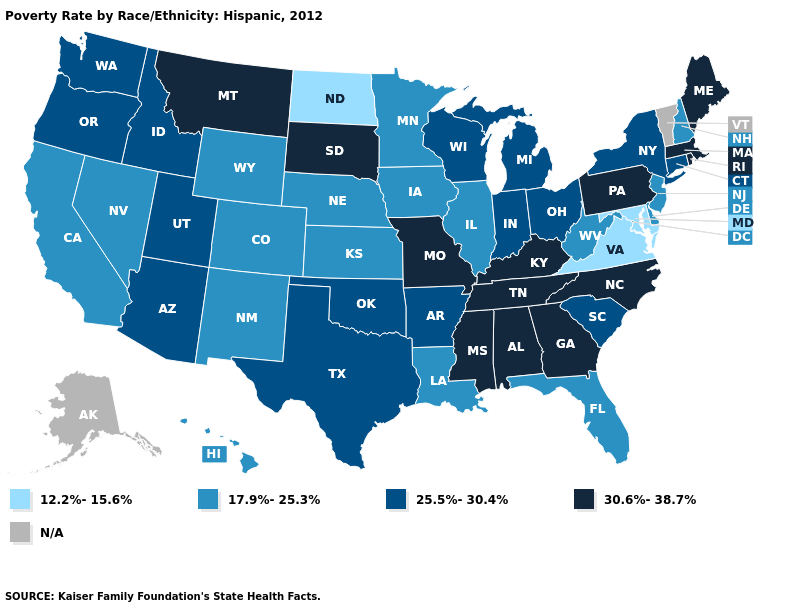What is the value of Florida?
Be succinct. 17.9%-25.3%. Among the states that border Utah , which have the highest value?
Keep it brief. Arizona, Idaho. What is the value of Michigan?
Concise answer only. 25.5%-30.4%. What is the value of Oklahoma?
Short answer required. 25.5%-30.4%. Among the states that border Maryland , does Pennsylvania have the lowest value?
Be succinct. No. Which states have the highest value in the USA?
Keep it brief. Alabama, Georgia, Kentucky, Maine, Massachusetts, Mississippi, Missouri, Montana, North Carolina, Pennsylvania, Rhode Island, South Dakota, Tennessee. What is the value of Texas?
Quick response, please. 25.5%-30.4%. What is the value of Mississippi?
Keep it brief. 30.6%-38.7%. What is the highest value in states that border Vermont?
Be succinct. 30.6%-38.7%. Does Arizona have the lowest value in the West?
Quick response, please. No. What is the value of Oregon?
Keep it brief. 25.5%-30.4%. Name the states that have a value in the range 17.9%-25.3%?
Keep it brief. California, Colorado, Delaware, Florida, Hawaii, Illinois, Iowa, Kansas, Louisiana, Minnesota, Nebraska, Nevada, New Hampshire, New Jersey, New Mexico, West Virginia, Wyoming. Name the states that have a value in the range 25.5%-30.4%?
Be succinct. Arizona, Arkansas, Connecticut, Idaho, Indiana, Michigan, New York, Ohio, Oklahoma, Oregon, South Carolina, Texas, Utah, Washington, Wisconsin. What is the value of Montana?
Short answer required. 30.6%-38.7%. 